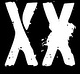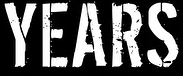Read the text from these images in sequence, separated by a semicolon. XX; YEARS 